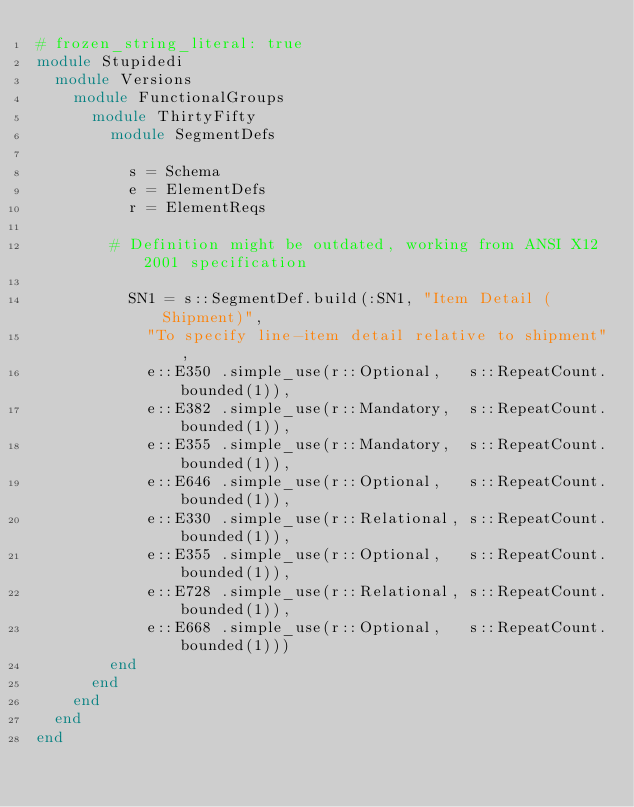Convert code to text. <code><loc_0><loc_0><loc_500><loc_500><_Ruby_># frozen_string_literal: true
module Stupidedi
  module Versions
    module FunctionalGroups
      module ThirtyFifty
        module SegmentDefs

          s = Schema
          e = ElementDefs
          r = ElementReqs

        # Definition might be outdated, working from ANSI X12 2001 specification

          SN1 = s::SegmentDef.build(:SN1, "Item Detail (Shipment)",
            "To specify line-item detail relative to shipment",
            e::E350 .simple_use(r::Optional,   s::RepeatCount.bounded(1)),
            e::E382 .simple_use(r::Mandatory,  s::RepeatCount.bounded(1)),
            e::E355 .simple_use(r::Mandatory,  s::RepeatCount.bounded(1)),
            e::E646 .simple_use(r::Optional,   s::RepeatCount.bounded(1)),
            e::E330 .simple_use(r::Relational, s::RepeatCount.bounded(1)),
            e::E355 .simple_use(r::Optional,   s::RepeatCount.bounded(1)),
            e::E728 .simple_use(r::Relational, s::RepeatCount.bounded(1)),
            e::E668 .simple_use(r::Optional,   s::RepeatCount.bounded(1)))
        end
      end
    end
  end
end
</code> 